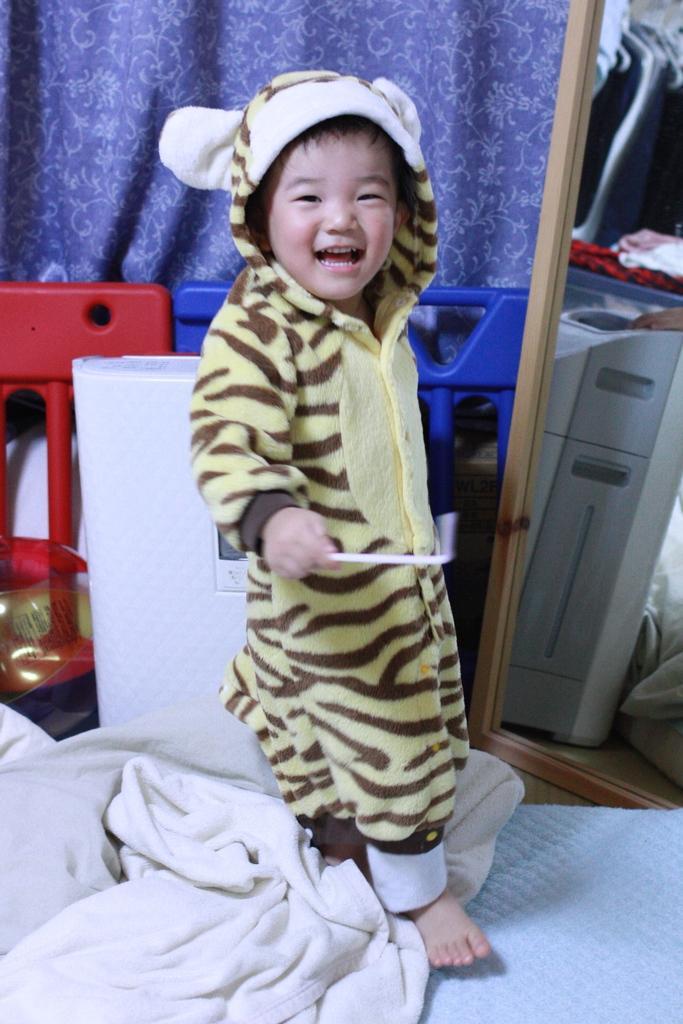Please provide a concise description of this image. In this picture we can see a kid, and the kid is smiling, beside to the kid we can find a machine, curtains and other things. 